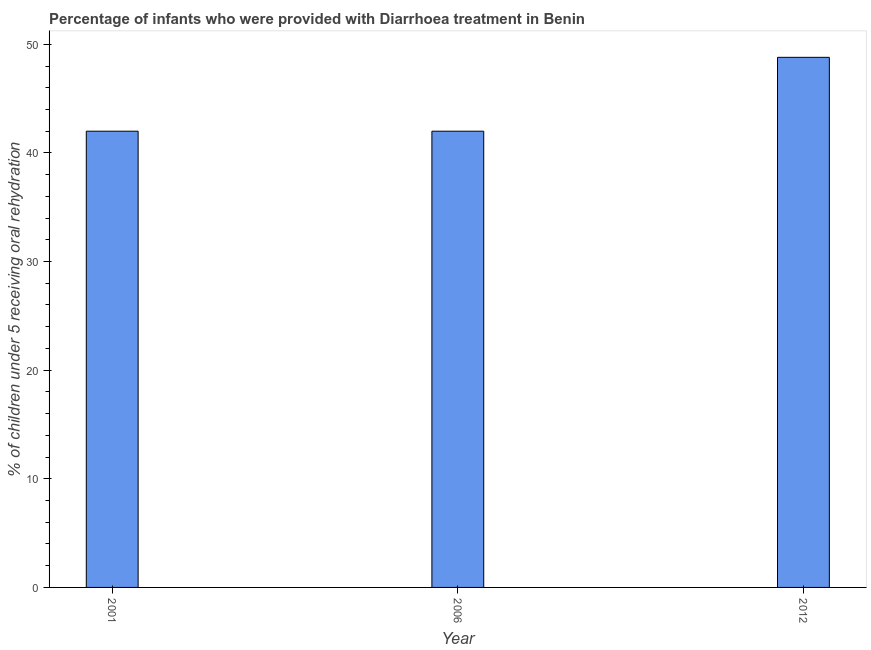Does the graph contain grids?
Keep it short and to the point. No. What is the title of the graph?
Offer a very short reply. Percentage of infants who were provided with Diarrhoea treatment in Benin. What is the label or title of the Y-axis?
Make the answer very short. % of children under 5 receiving oral rehydration. What is the percentage of children who were provided with treatment diarrhoea in 2001?
Keep it short and to the point. 42. Across all years, what is the maximum percentage of children who were provided with treatment diarrhoea?
Provide a short and direct response. 48.8. Across all years, what is the minimum percentage of children who were provided with treatment diarrhoea?
Your answer should be compact. 42. What is the sum of the percentage of children who were provided with treatment diarrhoea?
Offer a very short reply. 132.8. What is the average percentage of children who were provided with treatment diarrhoea per year?
Your answer should be compact. 44.27. What is the median percentage of children who were provided with treatment diarrhoea?
Offer a terse response. 42. What is the ratio of the percentage of children who were provided with treatment diarrhoea in 2006 to that in 2012?
Offer a very short reply. 0.86. Is the difference between the percentage of children who were provided with treatment diarrhoea in 2006 and 2012 greater than the difference between any two years?
Your response must be concise. Yes. What is the difference between the highest and the second highest percentage of children who were provided with treatment diarrhoea?
Provide a short and direct response. 6.8. Is the sum of the percentage of children who were provided with treatment diarrhoea in 2001 and 2006 greater than the maximum percentage of children who were provided with treatment diarrhoea across all years?
Ensure brevity in your answer.  Yes. What is the difference between the highest and the lowest percentage of children who were provided with treatment diarrhoea?
Provide a short and direct response. 6.8. In how many years, is the percentage of children who were provided with treatment diarrhoea greater than the average percentage of children who were provided with treatment diarrhoea taken over all years?
Provide a succinct answer. 1. Are the values on the major ticks of Y-axis written in scientific E-notation?
Ensure brevity in your answer.  No. What is the % of children under 5 receiving oral rehydration in 2012?
Keep it short and to the point. 48.8. What is the difference between the % of children under 5 receiving oral rehydration in 2006 and 2012?
Keep it short and to the point. -6.8. What is the ratio of the % of children under 5 receiving oral rehydration in 2001 to that in 2006?
Provide a short and direct response. 1. What is the ratio of the % of children under 5 receiving oral rehydration in 2001 to that in 2012?
Make the answer very short. 0.86. What is the ratio of the % of children under 5 receiving oral rehydration in 2006 to that in 2012?
Your answer should be compact. 0.86. 